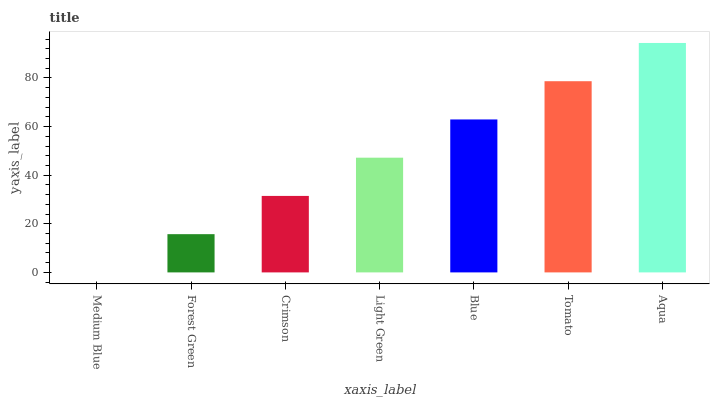Is Medium Blue the minimum?
Answer yes or no. Yes. Is Aqua the maximum?
Answer yes or no. Yes. Is Forest Green the minimum?
Answer yes or no. No. Is Forest Green the maximum?
Answer yes or no. No. Is Forest Green greater than Medium Blue?
Answer yes or no. Yes. Is Medium Blue less than Forest Green?
Answer yes or no. Yes. Is Medium Blue greater than Forest Green?
Answer yes or no. No. Is Forest Green less than Medium Blue?
Answer yes or no. No. Is Light Green the high median?
Answer yes or no. Yes. Is Light Green the low median?
Answer yes or no. Yes. Is Crimson the high median?
Answer yes or no. No. Is Blue the low median?
Answer yes or no. No. 